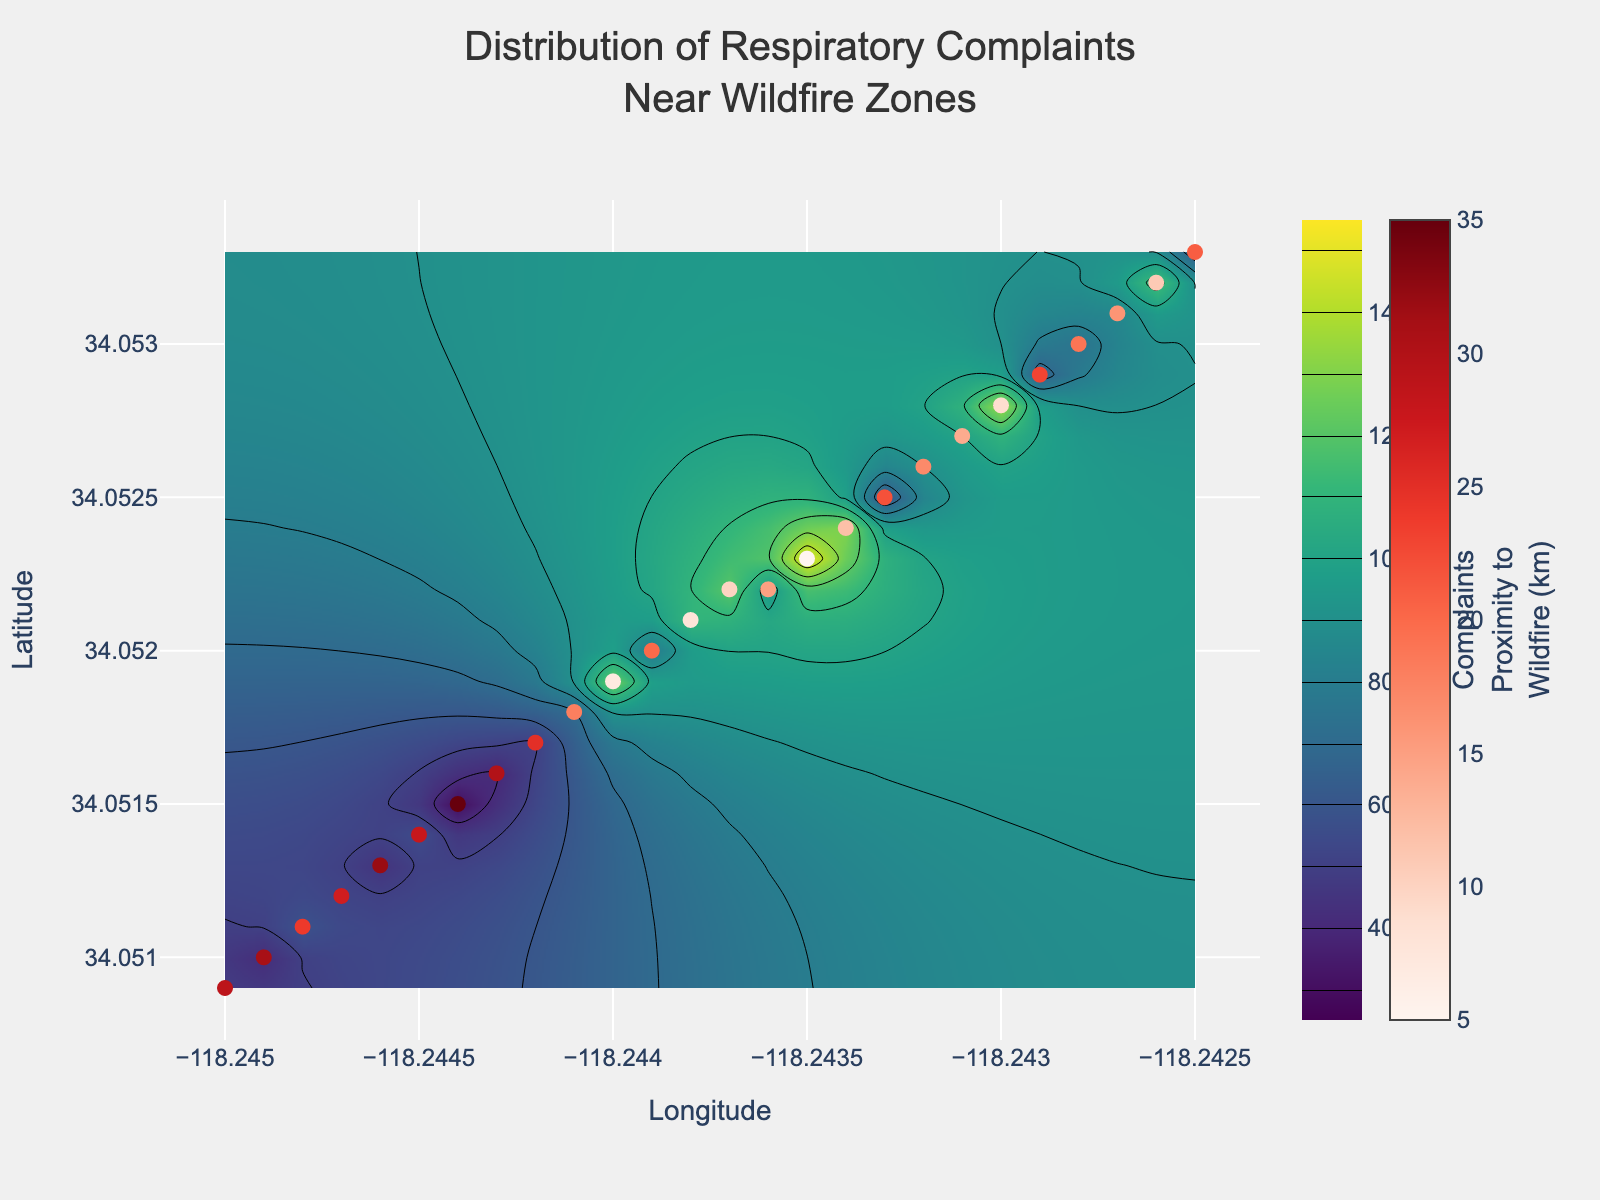What is the title of the figure? The title is clearly displayed at the top center of the figure in a larger font. It reads "Distribution of Respiratory Complaints Near Wildfire Zones."
Answer: Distribution of Respiratory Complaints Near Wildfire Zones What does the colorbar on the right side of the contour plot represent? The colorbar on the right side is labeled "Respiratory Complaints" and it shows different colors corresponding to the number of complaints, ranging from 30 to 150 as indicated by the color gradient.
Answer: Respiratory Complaints What do the colors in the scatter plot points indicate? The scatter plot points are colored using a Reds color scale which corresponds to "Proximity to Wildfire (km)" as indicated by the colorbar on the far right. The tooltip also shows the proximity in kilometers.
Answer: Proximity to Wildfire (km) Which longitude and latitude have the highest number of respiratory complaints? By observing the highest color intensity on the contour plot and checking the corresponding scatter plot point, it is found that the coordinates (34.0523, -118.2435) have the highest complaint count of 150.
Answer: (34.0523, -118.2435) Which data point has the lowest number of respiratory complaints and what is its proximity to the wildfire? The color representing the lowest value (dark color in the contour plot) corresponds to a data point with coordinates (34.0515, -118.2444) which has 30 complaints. The tooltip indicates that this point is 35 km from the wildfire.
Answer: (34.0515, -118.2444), 35 km Compare the respiratory complaints at coordinates (34.0520, -118.2439) and (34.0510, -118.2449). Which one has more complaints? At coordinates (34.0520, -118.2439), there are 80 complaints. At coordinates (34.0510, -118.2449), there are 42 complaints. Comparing these two values, 80 is greater than 42.
Answer: 34.0520, -118.2439 In terms of respiratory complaints, what is the vertical range of complaint numbers on the colorbar? The colorbar ranges from 30 at its lowest value to 150 at its highest value indicating the vertical range of respiratory complaints.
Answer: 30 to 150 How does the proximity to wildfire zones correlate with respiratory complaints in general? By inspecting the figure, it can be observed that areas with higher proximity to wildfire zones (indicated by brighter red scatter points) generally have higher respiratory complaints, shown by the more intense colors in the contour plot.
Answer: Generally, higher proximity correlates with more complaints Find the average respiratory complaints for the coordinates (34.0523, -118.2435) and (34.0518, -118.2441). The complaints at these coordinates are 150 and 70 respectively. The average is calculated by summing these two values (150 + 70 = 220) and then dividing by 2, which gives 110.
Answer: 110 What is the trend of respiratory complaints as the distance from the wildfire increases? The trend shows that respiratory complaints decrease as the distance from the wildfire increases, as indicated by the lower values and darker colors in areas farther from the central high proximity regions.
Answer: Decreases 